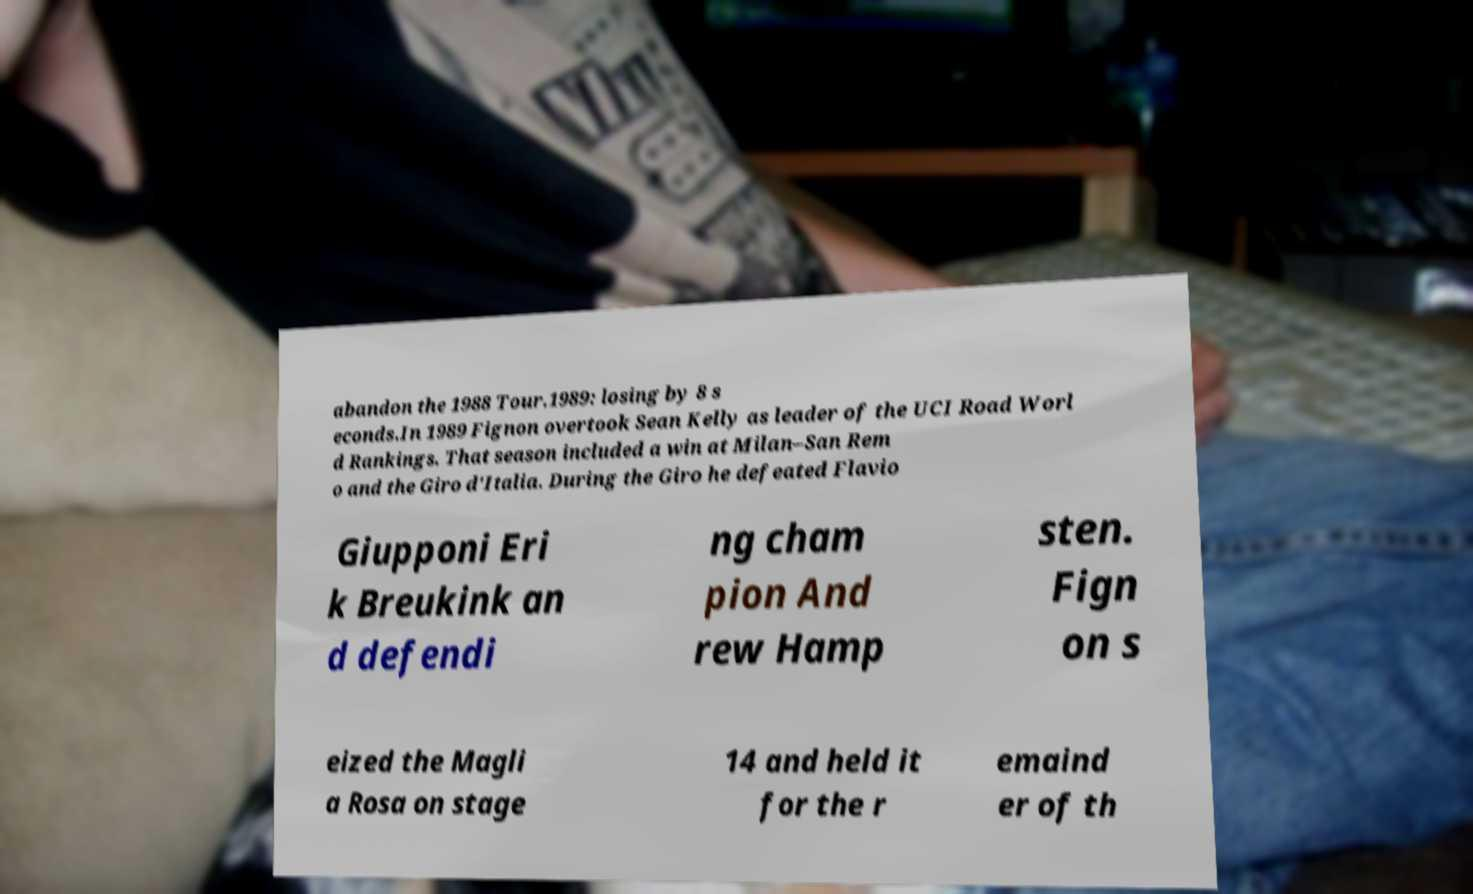Please read and relay the text visible in this image. What does it say? abandon the 1988 Tour.1989: losing by 8 s econds.In 1989 Fignon overtook Sean Kelly as leader of the UCI Road Worl d Rankings. That season included a win at Milan–San Rem o and the Giro d'Italia. During the Giro he defeated Flavio Giupponi Eri k Breukink an d defendi ng cham pion And rew Hamp sten. Fign on s eized the Magli a Rosa on stage 14 and held it for the r emaind er of th 